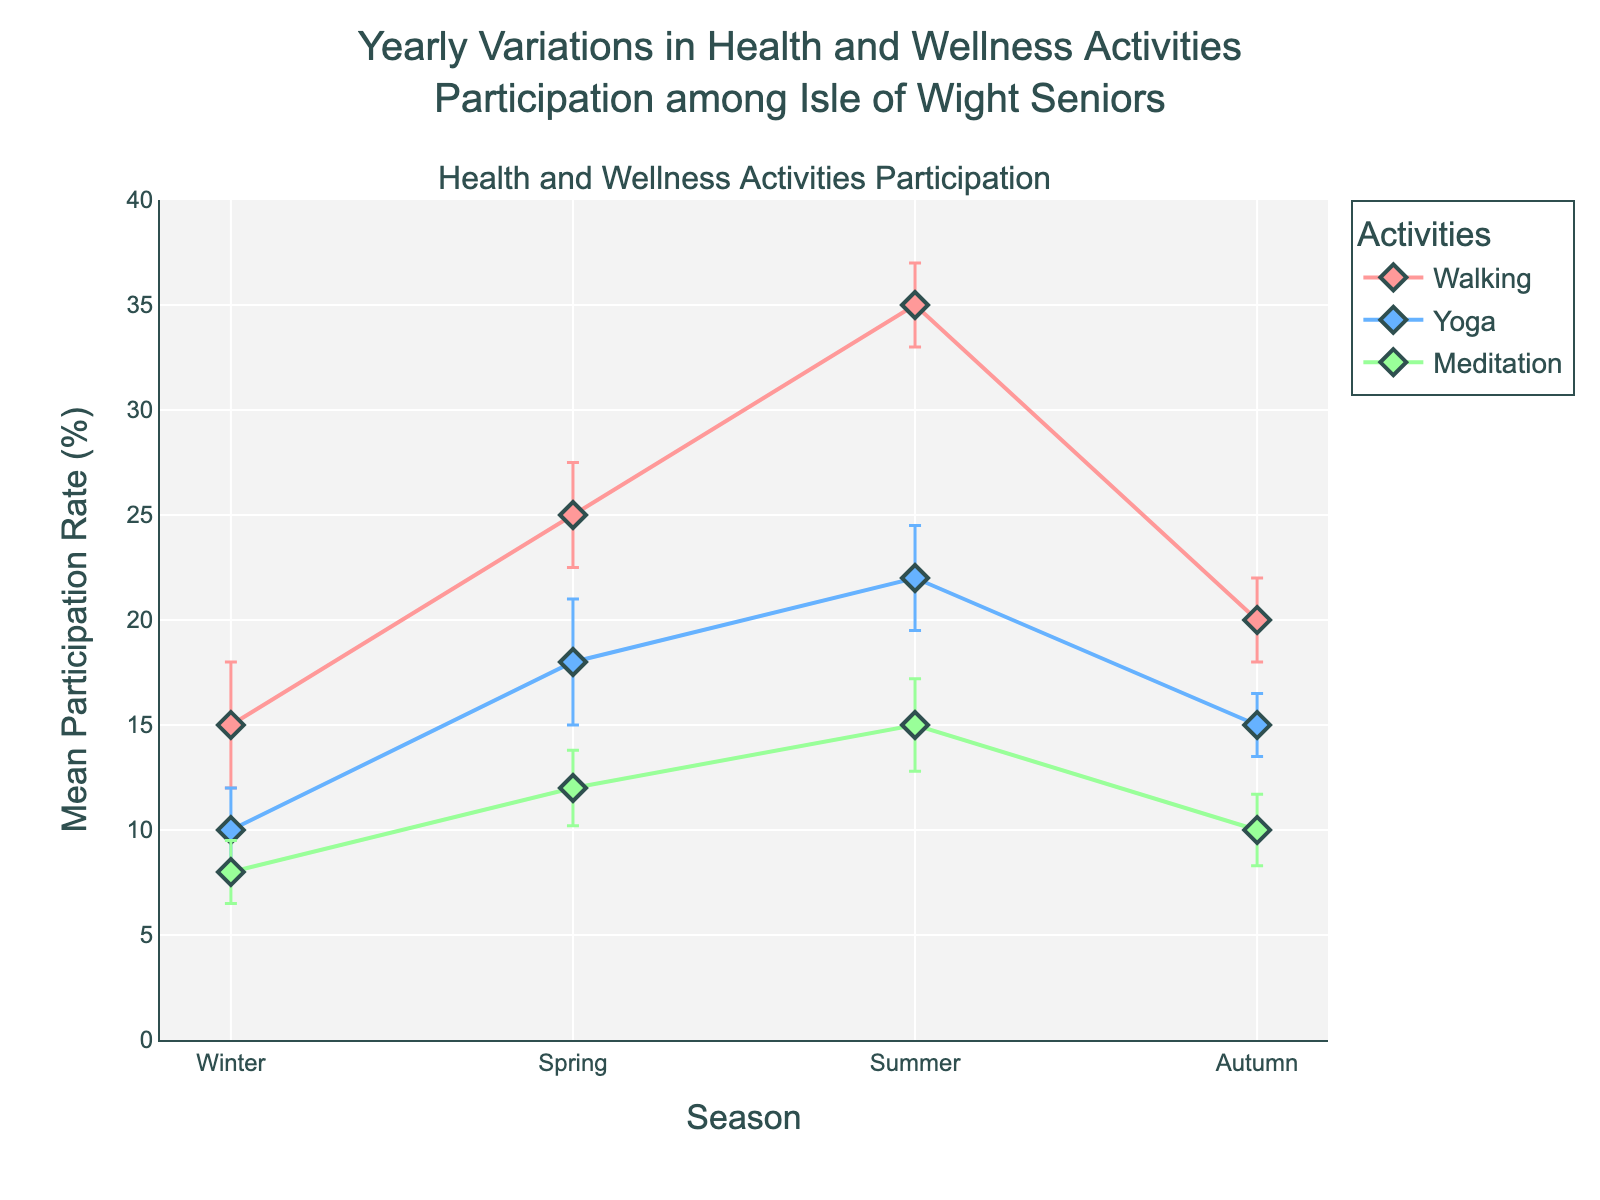What is the title of the plot? The title is found at the top of the figure.
Answer: Yearly Variations in Health and Wellness Activities Participation among Isle of Wight Seniors Which activity has the highest mean participation rate in summer? Look at the plotted lines and markers for each activity in the summer season and find the highest point on the y-axis.
Answer: Walking What is the mean participation rate for walking in autumn? Find the data point for walking in the autumn season and read the value from the y-axis.
Answer: 20% Which season shows the lowest mean participation rate for meditation? Identify the lowest point of the meditation line across all seasons and read the corresponding season from the x-axis.
Answer: Winter How many activities are tracked in the plot? Count the number of distinct lines representing different activities in the plot.
Answer: 3 What is the difference in mean participation rate for yoga between spring and autumn? Find the mean participation rates for yoga in both spring and autumn, and subtract the autumn rate from the spring rate.
Answer: 18% - 15% = 3% In which season does yoga have the higher mean participation rate compared to meditation? Compare the mean rates for yoga and meditation for each season and find the season where yoga's rate is greater.
Answer: All seasons Which activity shows the least variation in mean participation rate throughout the year? Compare the range of mean participation rates (maximum - minimum) for each activity, and find the activity with the smallest range.
Answer: Meditation What is the standard deviation of walking participation in winter? Identify the error bar for walking during the winter season and read its length, which represents the standard deviation.
Answer: 3% During which season does the participation rate for walking increase the most compared to the previous season? Look at the rise in the walking line from one season to another and identify the season with the steepest increase.
Answer: Spring to Summer 